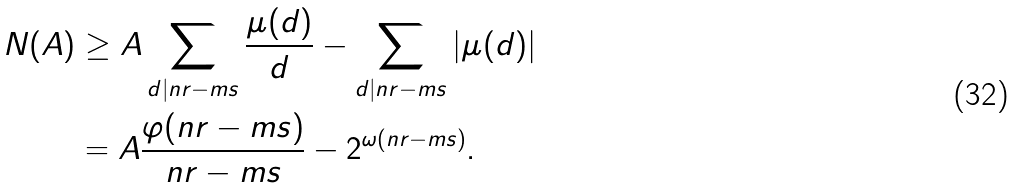Convert formula to latex. <formula><loc_0><loc_0><loc_500><loc_500>N ( A ) & \geq A \sum _ { d | n r - m s } \frac { \mu ( d ) } { d } - \sum _ { d | n r - m s } | \mu ( d ) | \\ & = A \frac { \varphi ( n r - m s ) } { n r - m s } - 2 ^ { \omega ( n r - m s ) } .</formula> 